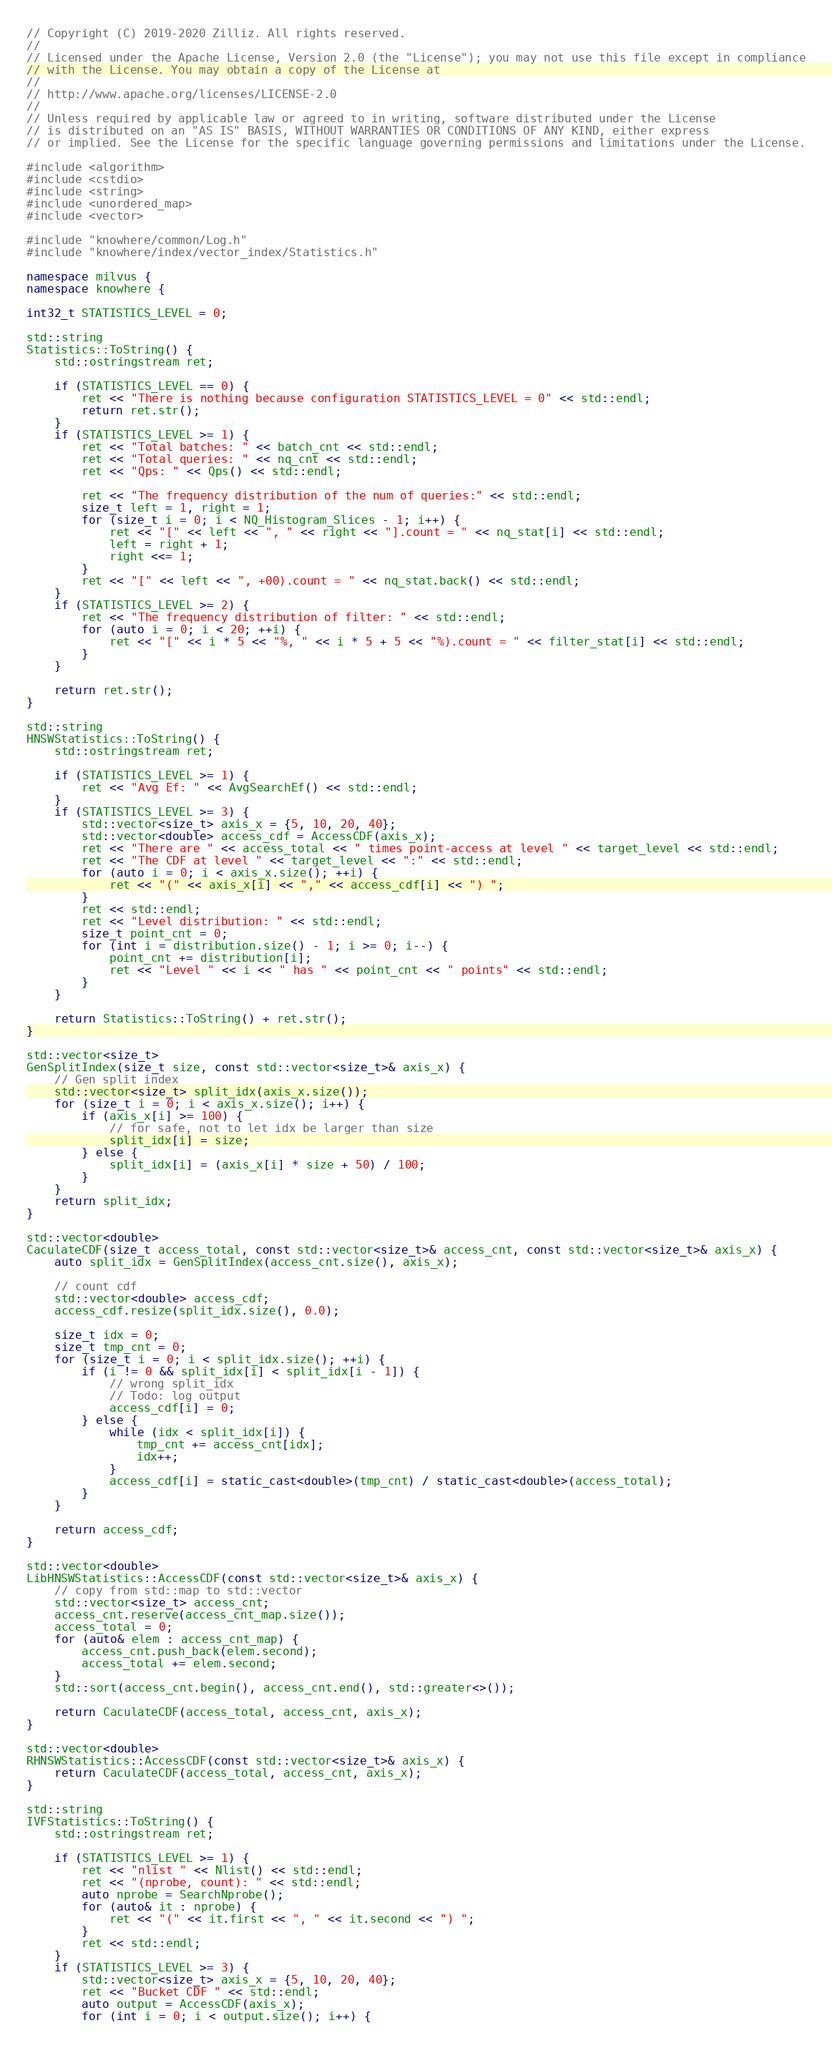<code> <loc_0><loc_0><loc_500><loc_500><_C++_>// Copyright (C) 2019-2020 Zilliz. All rights reserved.
//
// Licensed under the Apache License, Version 2.0 (the "License"); you may not use this file except in compliance
// with the License. You may obtain a copy of the License at
//
// http://www.apache.org/licenses/LICENSE-2.0
//
// Unless required by applicable law or agreed to in writing, software distributed under the License
// is distributed on an "AS IS" BASIS, WITHOUT WARRANTIES OR CONDITIONS OF ANY KIND, either express
// or implied. See the License for the specific language governing permissions and limitations under the License.

#include <algorithm>
#include <cstdio>
#include <string>
#include <unordered_map>
#include <vector>

#include "knowhere/common/Log.h"
#include "knowhere/index/vector_index/Statistics.h"

namespace milvus {
namespace knowhere {

int32_t STATISTICS_LEVEL = 0;

std::string
Statistics::ToString() {
    std::ostringstream ret;

    if (STATISTICS_LEVEL == 0) {
        ret << "There is nothing because configuration STATISTICS_LEVEL = 0" << std::endl;
        return ret.str();
    }
    if (STATISTICS_LEVEL >= 1) {
        ret << "Total batches: " << batch_cnt << std::endl;
        ret << "Total queries: " << nq_cnt << std::endl;
        ret << "Qps: " << Qps() << std::endl;

        ret << "The frequency distribution of the num of queries:" << std::endl;
        size_t left = 1, right = 1;
        for (size_t i = 0; i < NQ_Histogram_Slices - 1; i++) {
            ret << "[" << left << ", " << right << "].count = " << nq_stat[i] << std::endl;
            left = right + 1;
            right <<= 1;
        }
        ret << "[" << left << ", +00).count = " << nq_stat.back() << std::endl;
    }
    if (STATISTICS_LEVEL >= 2) {
        ret << "The frequency distribution of filter: " << std::endl;
        for (auto i = 0; i < 20; ++i) {
            ret << "[" << i * 5 << "%, " << i * 5 + 5 << "%).count = " << filter_stat[i] << std::endl;
        }
    }

    return ret.str();
}

std::string
HNSWStatistics::ToString() {
    std::ostringstream ret;

    if (STATISTICS_LEVEL >= 1) {
        ret << "Avg Ef: " << AvgSearchEf() << std::endl;
    }
    if (STATISTICS_LEVEL >= 3) {
        std::vector<size_t> axis_x = {5, 10, 20, 40};
        std::vector<double> access_cdf = AccessCDF(axis_x);
        ret << "There are " << access_total << " times point-access at level " << target_level << std::endl;
        ret << "The CDF at level " << target_level << ":" << std::endl;
        for (auto i = 0; i < axis_x.size(); ++i) {
            ret << "(" << axis_x[i] << "," << access_cdf[i] << ") ";
        }
        ret << std::endl;
        ret << "Level distribution: " << std::endl;
        size_t point_cnt = 0;
        for (int i = distribution.size() - 1; i >= 0; i--) {
            point_cnt += distribution[i];
            ret << "Level " << i << " has " << point_cnt << " points" << std::endl;
        }
    }

    return Statistics::ToString() + ret.str();
}

std::vector<size_t>
GenSplitIndex(size_t size, const std::vector<size_t>& axis_x) {
    // Gen split index
    std::vector<size_t> split_idx(axis_x.size());
    for (size_t i = 0; i < axis_x.size(); i++) {
        if (axis_x[i] >= 100) {
            // for safe, not to let idx be larger than size
            split_idx[i] = size;
        } else {
            split_idx[i] = (axis_x[i] * size + 50) / 100;
        }
    }
    return split_idx;
}

std::vector<double>
CaculateCDF(size_t access_total, const std::vector<size_t>& access_cnt, const std::vector<size_t>& axis_x) {
    auto split_idx = GenSplitIndex(access_cnt.size(), axis_x);

    // count cdf
    std::vector<double> access_cdf;
    access_cdf.resize(split_idx.size(), 0.0);

    size_t idx = 0;
    size_t tmp_cnt = 0;
    for (size_t i = 0; i < split_idx.size(); ++i) {
        if (i != 0 && split_idx[i] < split_idx[i - 1]) {
            // wrong split_idx
            // Todo: log output
            access_cdf[i] = 0;
        } else {
            while (idx < split_idx[i]) {
                tmp_cnt += access_cnt[idx];
                idx++;
            }
            access_cdf[i] = static_cast<double>(tmp_cnt) / static_cast<double>(access_total);
        }
    }

    return access_cdf;
}

std::vector<double>
LibHNSWStatistics::AccessCDF(const std::vector<size_t>& axis_x) {
    // copy from std::map to std::vector
    std::vector<size_t> access_cnt;
    access_cnt.reserve(access_cnt_map.size());
    access_total = 0;
    for (auto& elem : access_cnt_map) {
        access_cnt.push_back(elem.second);
        access_total += elem.second;
    }
    std::sort(access_cnt.begin(), access_cnt.end(), std::greater<>());

    return CaculateCDF(access_total, access_cnt, axis_x);
}

std::vector<double>
RHNSWStatistics::AccessCDF(const std::vector<size_t>& axis_x) {
    return CaculateCDF(access_total, access_cnt, axis_x);
}

std::string
IVFStatistics::ToString() {
    std::ostringstream ret;

    if (STATISTICS_LEVEL >= 1) {
        ret << "nlist " << Nlist() << std::endl;
        ret << "(nprobe, count): " << std::endl;
        auto nprobe = SearchNprobe();
        for (auto& it : nprobe) {
            ret << "(" << it.first << ", " << it.second << ") ";
        }
        ret << std::endl;
    }
    if (STATISTICS_LEVEL >= 3) {
        std::vector<size_t> axis_x = {5, 10, 20, 40};
        ret << "Bucket CDF " << std::endl;
        auto output = AccessCDF(axis_x);
        for (int i = 0; i < output.size(); i++) {</code> 